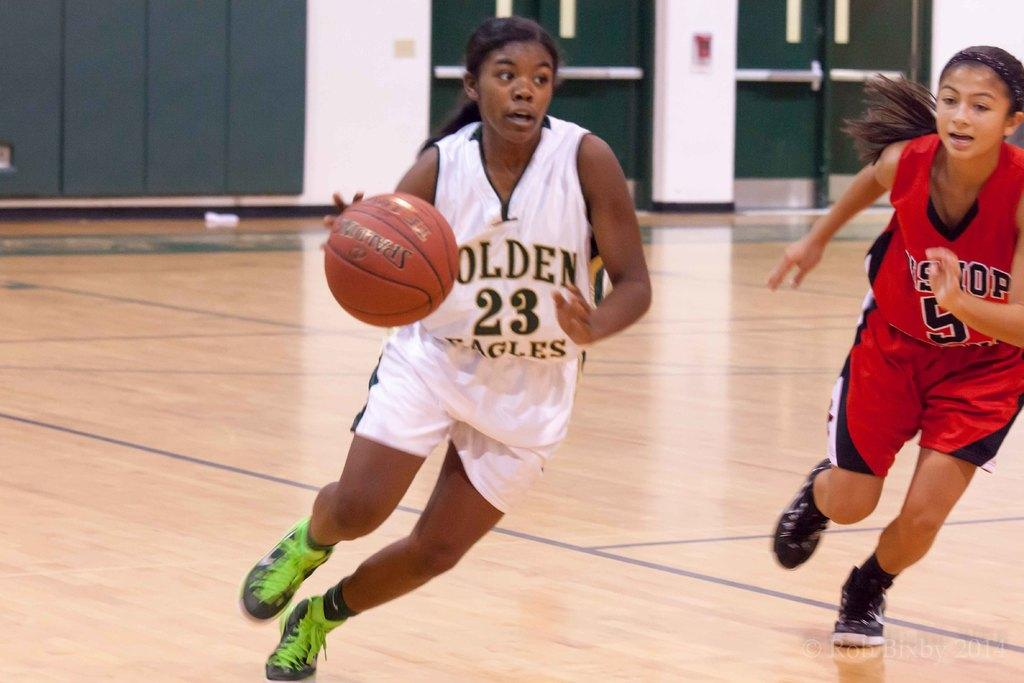<image>
Provide a brief description of the given image. Player number 23 is running with the ball. 